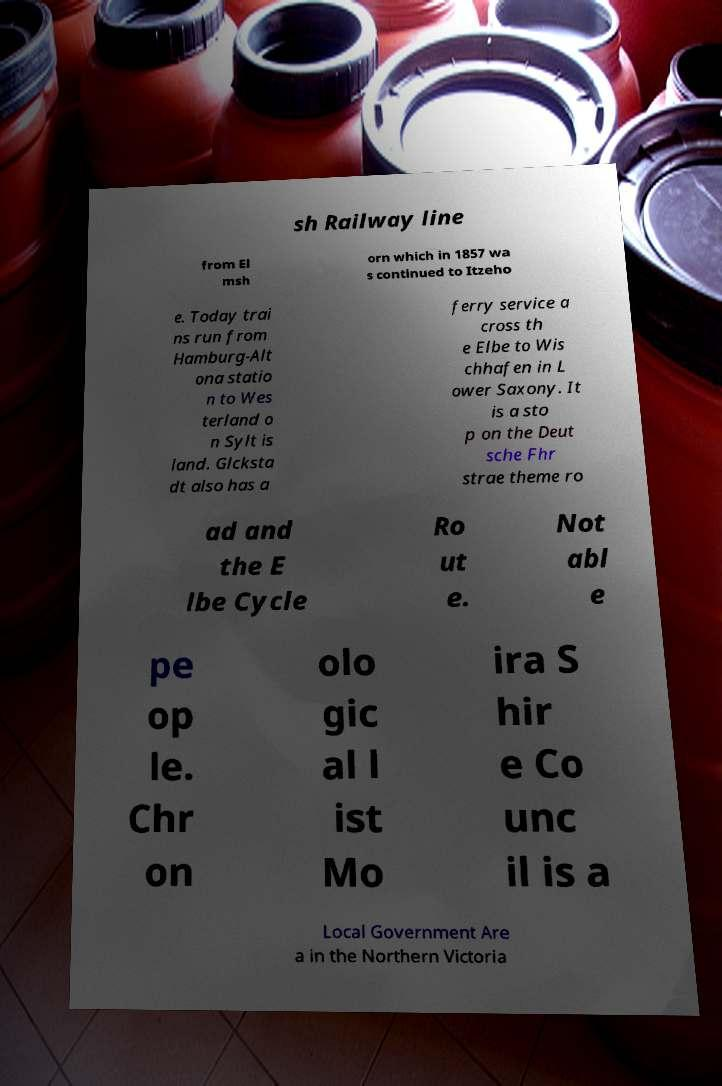Can you read and provide the text displayed in the image?This photo seems to have some interesting text. Can you extract and type it out for me? sh Railway line from El msh orn which in 1857 wa s continued to Itzeho e. Today trai ns run from Hamburg-Alt ona statio n to Wes terland o n Sylt is land. Glcksta dt also has a ferry service a cross th e Elbe to Wis chhafen in L ower Saxony. It is a sto p on the Deut sche Fhr strae theme ro ad and the E lbe Cycle Ro ut e. Not abl e pe op le. Chr on olo gic al l ist Mo ira S hir e Co unc il is a Local Government Are a in the Northern Victoria 